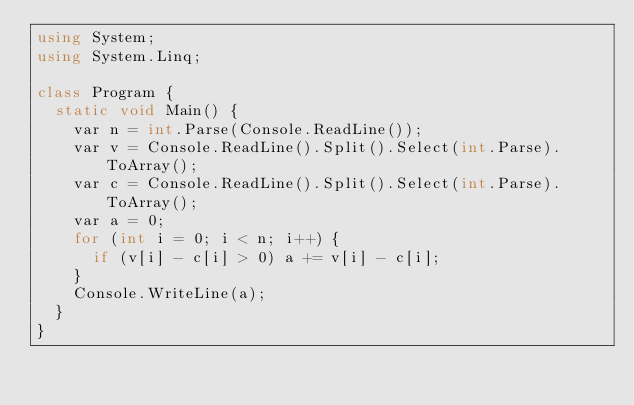Convert code to text. <code><loc_0><loc_0><loc_500><loc_500><_C#_>using System;
using System.Linq;

class Program {
  static void Main() {
    var n = int.Parse(Console.ReadLine());
    var v = Console.ReadLine().Split().Select(int.Parse).ToArray();
    var c = Console.ReadLine().Split().Select(int.Parse).ToArray();
    var a = 0;
    for (int i = 0; i < n; i++) {
      if (v[i] - c[i] > 0) a += v[i] - c[i];
    }
    Console.WriteLine(a);
  }
}</code> 